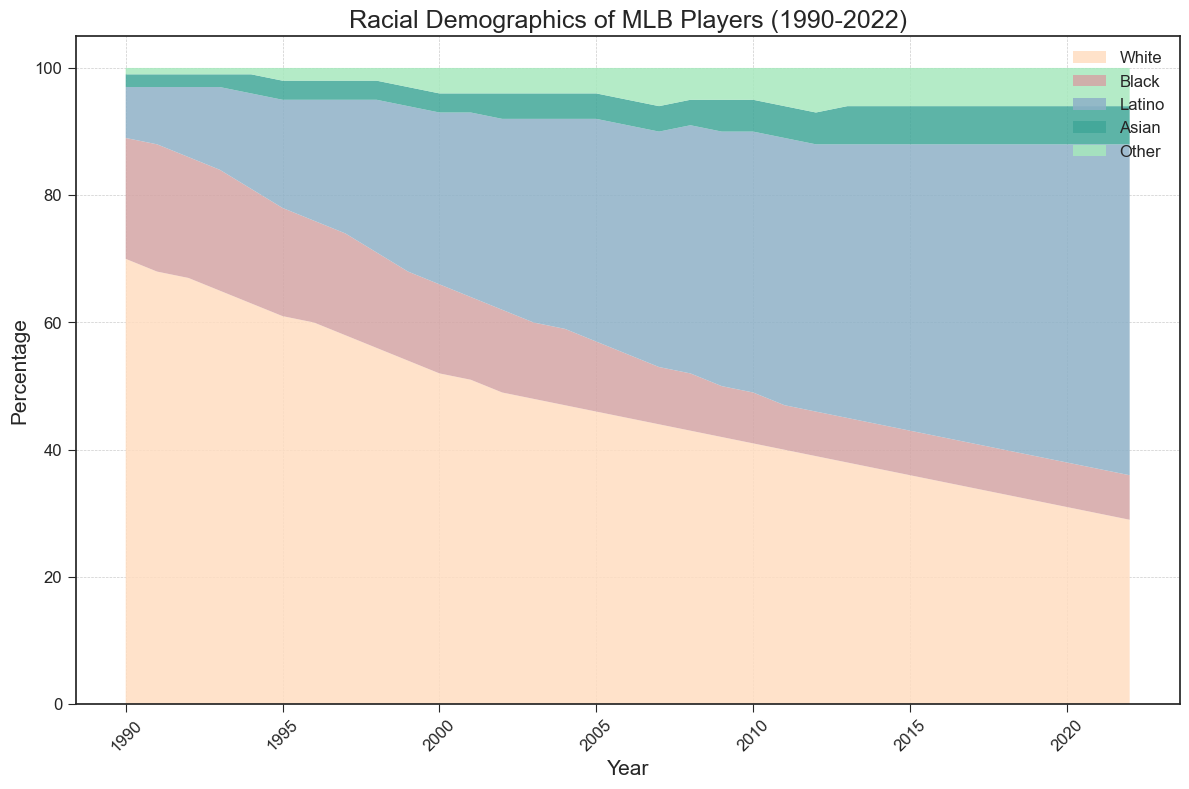What is the overall trend of the percentage of White players from 1990 to 2022? The percentage of White players shows a continuous decline over the years. Starting from 70% in 1990, it drops steadily to 29% in 2022.
Answer: Continuous decline How does the percentage of Black players change from 1990 to 2022? The percentage of Black players decreases from 19% in 1990 to 7% in 2022. This decline is relatively consistent over the years.
Answer: Decrease Which racial or ethnic group shows the most significant increase in percentage from 1990 to 2022? By visually inspecting the area chart, it's clear that Latino players show a significant increase from 8% in 1990 to 52% in 2022. This is the largest growth among all groups.
Answer: Latino Compare the percentage of Latino players with that of White players in 2010. In 2010, the percentage of Latino players is 41% while the percentage of White players is 41%. They are equal in this year.
Answer: Equal In what year did the percentage of Latino players exceed that of White players for the first time? By visual inspection, we see that the lines for White and Latino percentages cross between 2009 and 2010. In 2010, both percentages are 41%, and starting from 2011, the Latino percentage consistently exceeds the White percentage. Thus, it first exceeded in 2010.
Answer: 2010 What is the percentage difference between White and Latino players in 2022? The percentage of White players in 2022 is 29%, while the percentage of Latino players is 52%. The difference is 52% - 29% = 23%.
Answer: 23% Which group has the least percentage change over the years? By observing the chart, the 'Asian' group shows relatively small changes, starting at 2% in 1990 and rising to 6% in 2022.
Answer: Asian What overall pattern can be seen in the demographic labeled 'Other'? The 'Other' category shows a slight increase from 1% in 1990 to 6% in 2022, indicating slow but steady growth over the years.
Answer: Slow growth Compare the sums of the percentages of Asian and Other players in 1990 and 2022. In 1990, the percentage sum for Asian (2%) and Other (1%) is 3%. In 2022, the sum for Asian (6%) and Other (6%) is 12%. Hence, the sum increases from 3% to 12% over the years.
Answer: From 3% to 12% Among the colored segments in the area chart, which color represents Latino players, and what visual cue helps identify it? The section representing Latino players has a blueish color. It is identified by its position in the stack and its significant growth over time, occupying a larger area in later years.
Answer: Blueish color 